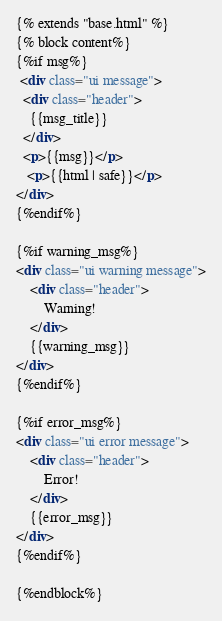<code> <loc_0><loc_0><loc_500><loc_500><_HTML_>{% extends "base.html" %}
{% block content%}
{%if msg%}
 <div class="ui message">
  <div class="header">
    {{msg_title}}
  </div>
  <p>{{msg}}</p>
   <p>{{html | safe}}</p>
</div>
{%endif%}

{%if warning_msg%}
<div class="ui warning message">
    <div class="header">
        Warning!
    </div>
    {{warning_msg}}
</div>
{%endif%}

{%if error_msg%}
<div class="ui error message">
    <div class="header">
        Error!
    </div>
    {{error_msg}}
</div>
{%endif%}

{%endblock%}</code> 